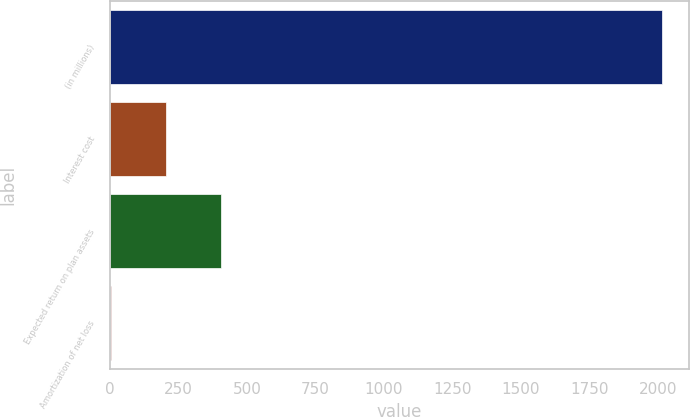Convert chart. <chart><loc_0><loc_0><loc_500><loc_500><bar_chart><fcel>(in millions)<fcel>Interest cost<fcel>Expected return on plan assets<fcel>Amortization of net loss<nl><fcel>2013<fcel>204<fcel>405<fcel>3<nl></chart> 